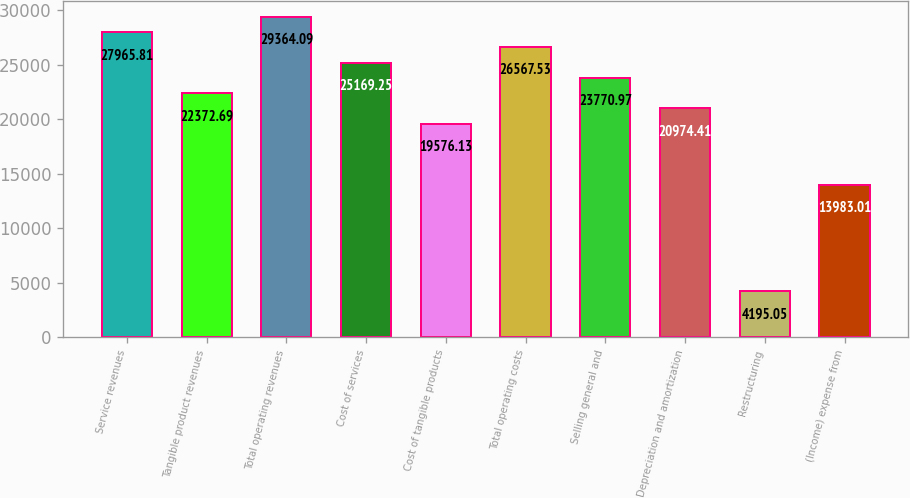Convert chart to OTSL. <chart><loc_0><loc_0><loc_500><loc_500><bar_chart><fcel>Service revenues<fcel>Tangible product revenues<fcel>Total operating revenues<fcel>Cost of services<fcel>Cost of tangible products<fcel>Total operating costs<fcel>Selling general and<fcel>Depreciation and amortization<fcel>Restructuring<fcel>(Income) expense from<nl><fcel>27965.8<fcel>22372.7<fcel>29364.1<fcel>25169.2<fcel>19576.1<fcel>26567.5<fcel>23771<fcel>20974.4<fcel>4195.05<fcel>13983<nl></chart> 